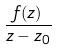Convert formula to latex. <formula><loc_0><loc_0><loc_500><loc_500>\frac { f ( z ) } { z - z _ { 0 } }</formula> 